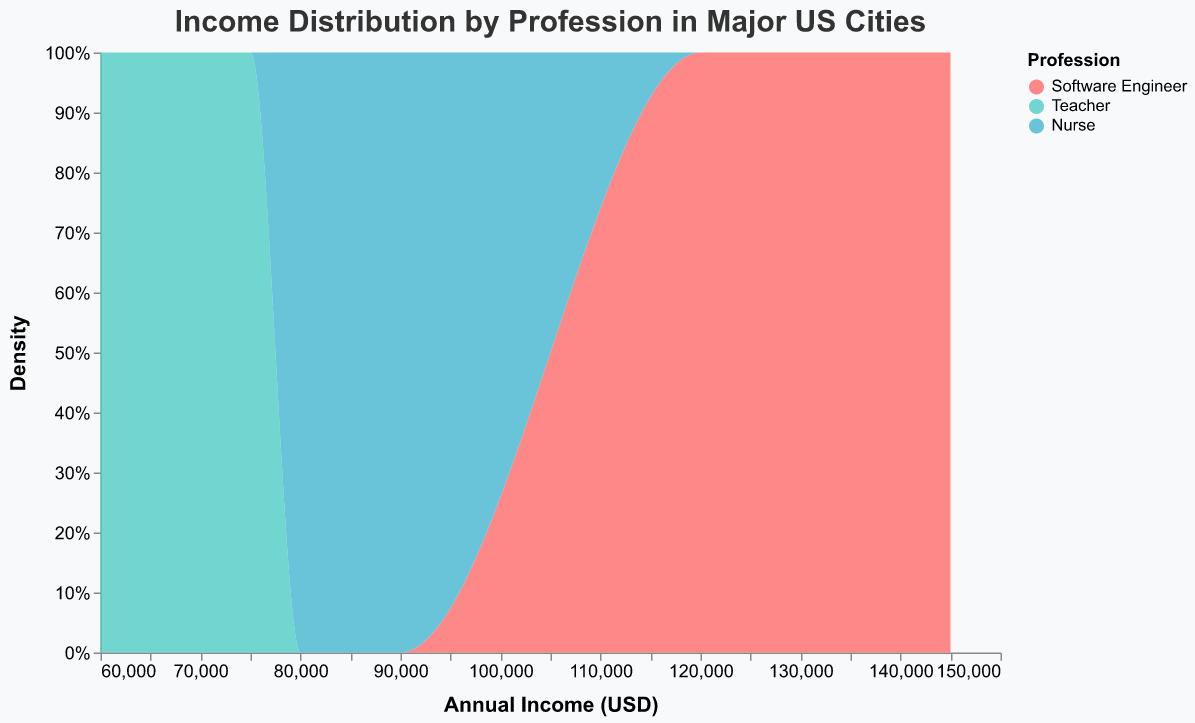What's the title of the figure? The title is displayed at the top of the figure. It reads "Income Distribution by Profession in Major US Cities".
Answer: Income Distribution by Profession in Major US Cities What professions are represented in the figure? The legend on the right side of the figure lists the three professions: Software Engineer, Teacher, and Nurse. Each profession is associated with a different color.
Answer: Software Engineer, Teacher, Nurse Which profession appears to have the highest income density? Observing the figure, the area representing Software Engineers is positioned towards the higher income values compared to Teachers and Nurses, indicating a higher income density.
Answer: Software Engineer What is the range of income values displayed on the x-axis? The x-axis is labeled "Annual Income (USD)" and shows a range from approximately $60,000 to $150,000 based on the axis ticks.
Answer: $60,000 to $150,000 Which profession's income distribution has the lowest density towards the higher income values? The plot shows that the area for Teachers is less dense towards the higher income values when compared to Software Engineers and Nurses.
Answer: Teacher Is the income distribution for Nurses closer to Software Engineers or Teachers? The income distribution for Nurses is visually more similar to that of Teachers, but is generally higher. Both are positioned in the middle range, while Software Engineers have a higher distribution overall.
Answer: Teachers Do the income distributions for any professions overlap significantly? The colored areas for Nurses and Teachers overlap significantly in the middle income range, indicating similarities in their income distributions.
Answer: Yes, Nurses and Teachers Which profession has the most diverse range of incomes? The income distribution for Software Engineers, spanning from lower to higher income values, suggests a more diverse range of incomes compared to the more narrowly distributed incomes for Teachers and Nurses.
Answer: Software Engineer 